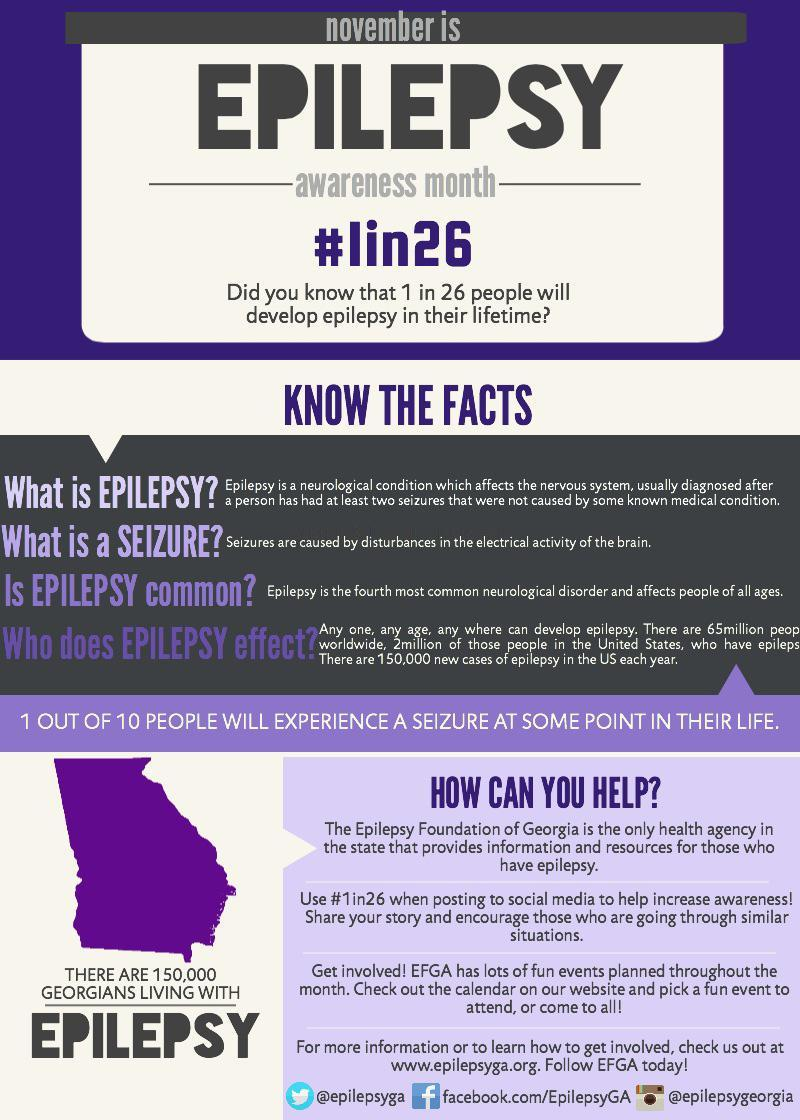What is the reason for seizures in epilepsy?
Answer the question with a short phrase. disturbances in the electrical activity of the brain How many people in the state of Georgia are affected by epilepsy? 150,000 